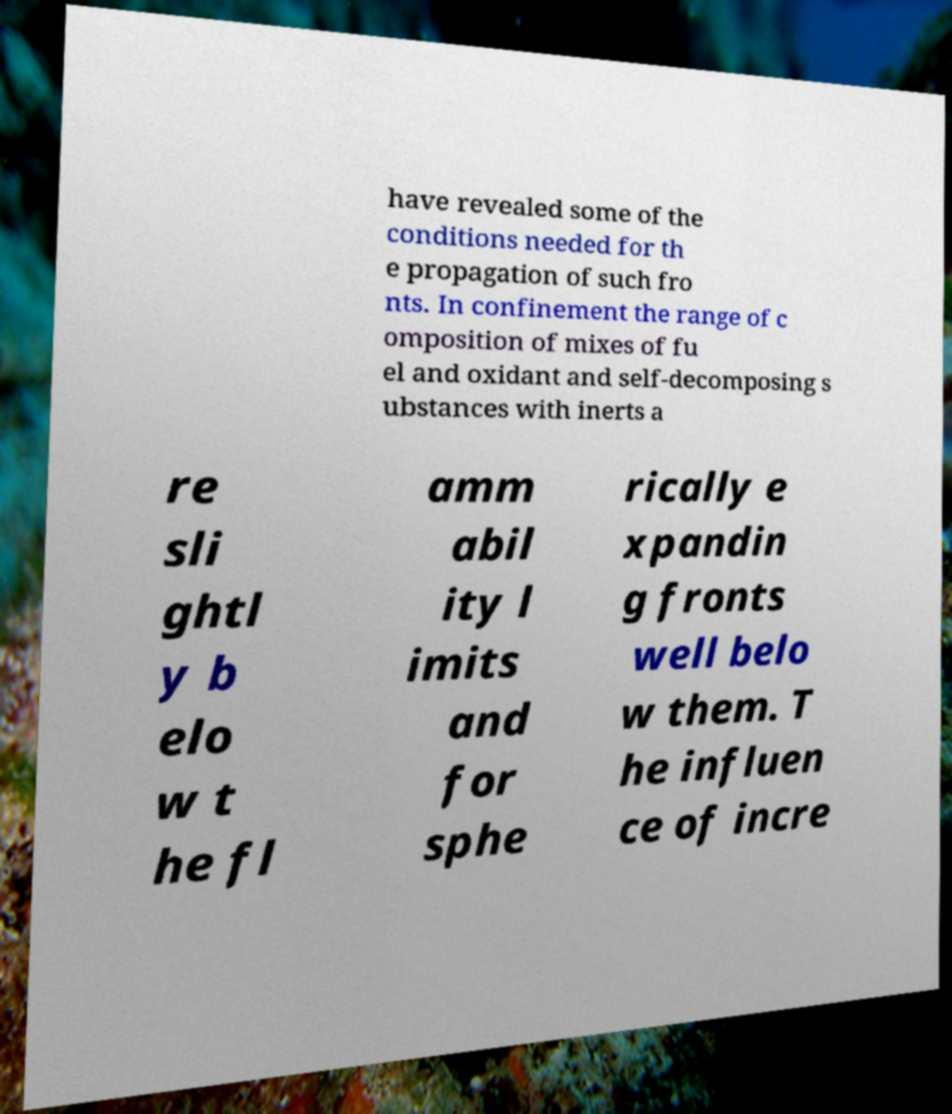Please read and relay the text visible in this image. What does it say? have revealed some of the conditions needed for th e propagation of such fro nts. In confinement the range of c omposition of mixes of fu el and oxidant and self-decomposing s ubstances with inerts a re sli ghtl y b elo w t he fl amm abil ity l imits and for sphe rically e xpandin g fronts well belo w them. T he influen ce of incre 